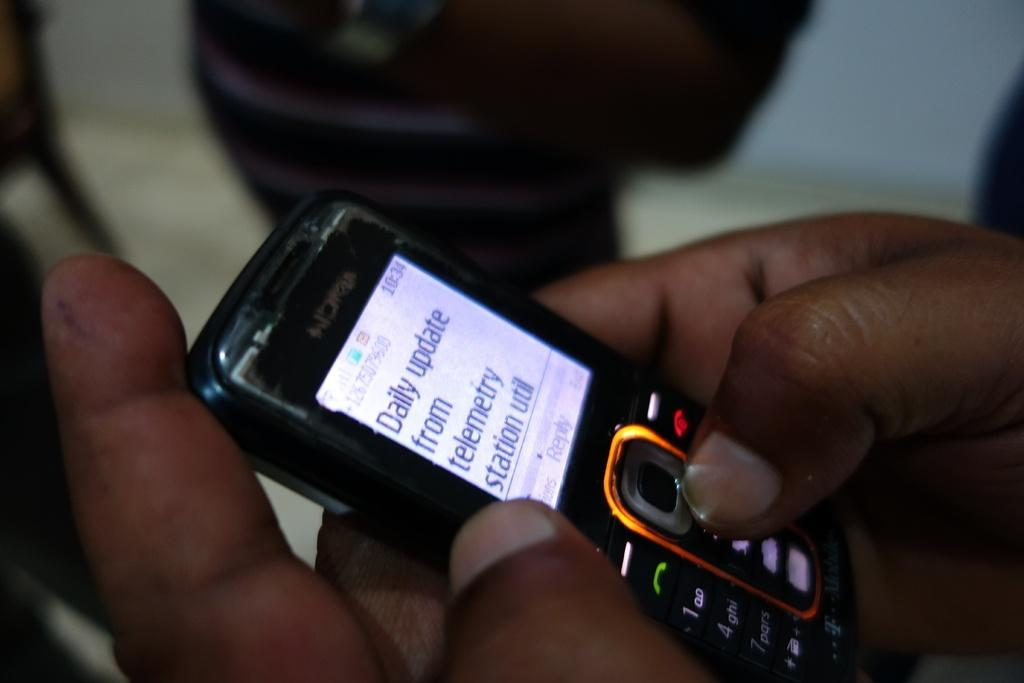<image>
Give a short and clear explanation of the subsequent image. An individual is checking their daily updates on a small cell phone. 